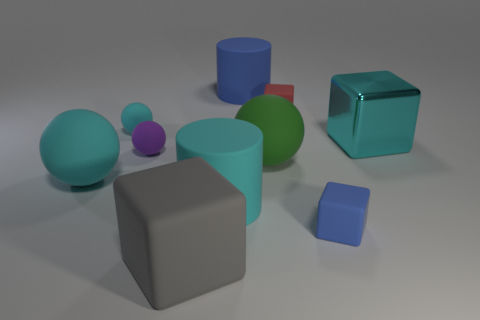Subtract all red blocks. How many blocks are left? 3 Subtract all blue cylinders. How many cylinders are left? 1 Subtract all balls. How many objects are left? 6 Subtract 3 blocks. How many blocks are left? 1 Subtract all cyan cylinders. Subtract all green blocks. How many cylinders are left? 1 Subtract all red cylinders. How many cyan spheres are left? 2 Subtract all matte things. Subtract all red objects. How many objects are left? 0 Add 4 cyan objects. How many cyan objects are left? 8 Add 3 large cyan shiny things. How many large cyan shiny things exist? 4 Subtract 0 gray cylinders. How many objects are left? 10 